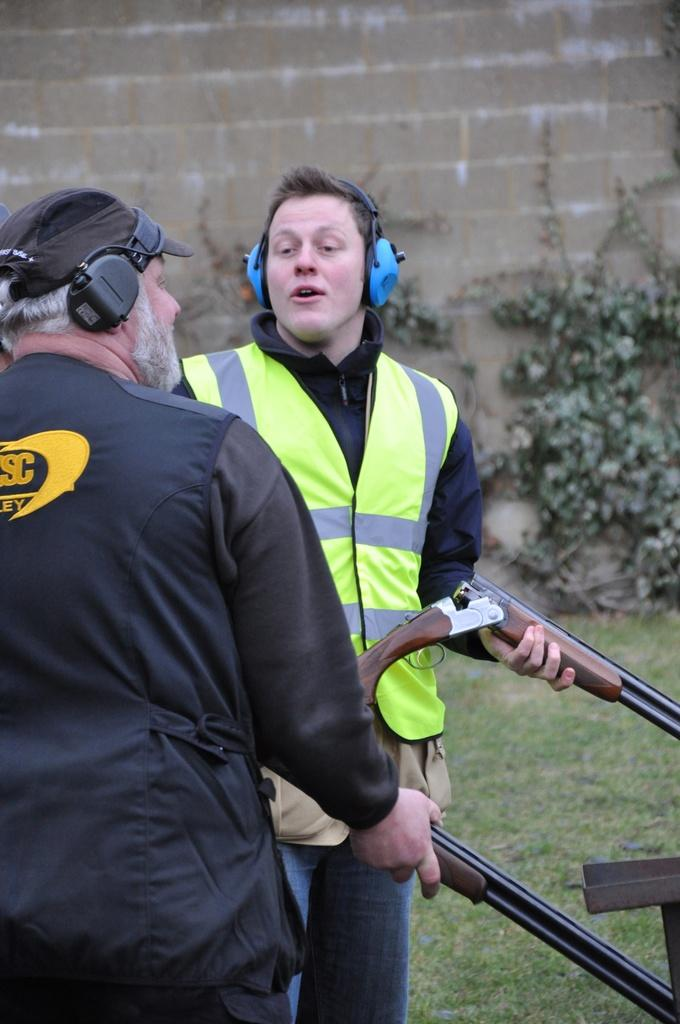What is the main subject in the middle of the image? There is a man in the middle of the image. What is the man in the middle holding? The man in the middle is holding a gun. What is the position of the man on the left side of the image? There is a man on the left side of the image. What is the man on the left holding? The man on the left is holding a gun. What can be seen in the background of the image? There are plants, grass, and a wall in the background of the image. What type of produce is being sold at the downtown market in the image? There is no downtown market or produce present in the image; it features two men holding guns and a background with plants, grass, and a wall. 